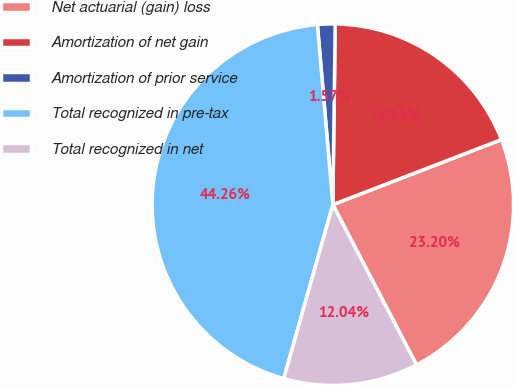<chart> <loc_0><loc_0><loc_500><loc_500><pie_chart><fcel>Net actuarial (gain) loss<fcel>Amortization of net gain<fcel>Amortization of prior service<fcel>Total recognized in pre-tax<fcel>Total recognized in net<nl><fcel>23.2%<fcel>18.93%<fcel>1.57%<fcel>44.26%<fcel>12.04%<nl></chart> 